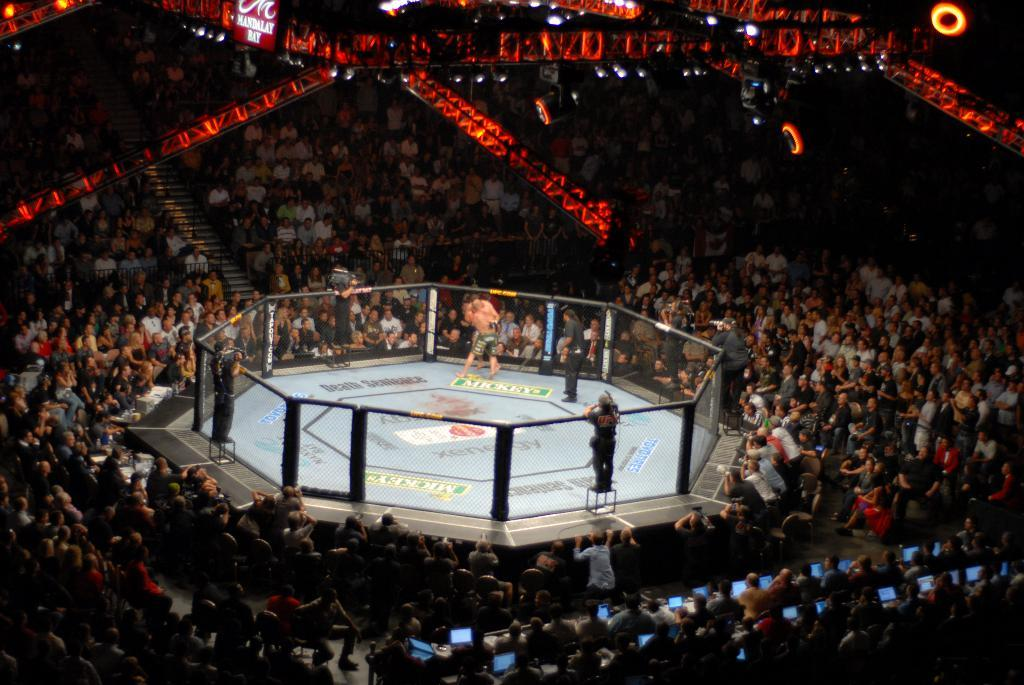What type of structure is in the image? There is an UFC ring in the image. What is happening inside the UFC ring? There are people inside the UFC ring. Are there any spectators or other people around the UFC ring? Yes, there are people sitting and standing around the UFC ring. What can be seen on the roof in the image? There are lights visible on the roof in the image. How does the square connect to the UFC ring in the image? There is no square present in the image, and therefore no connection can be observed. 